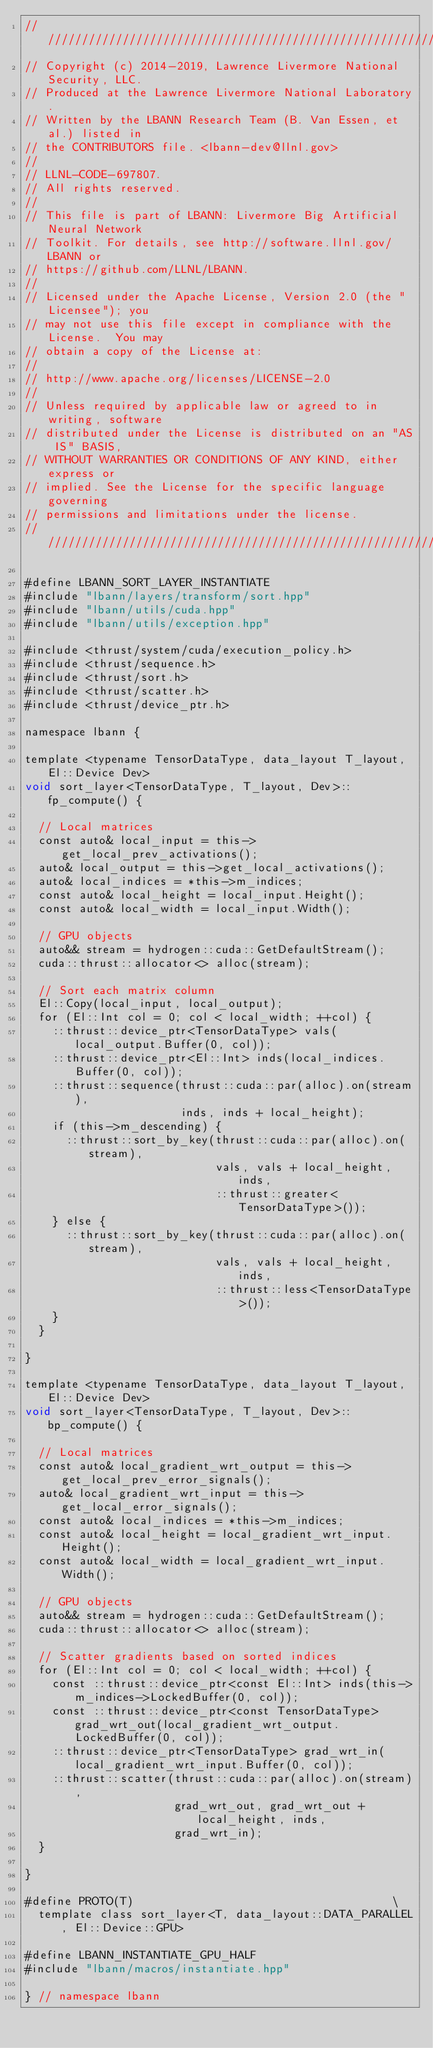Convert code to text. <code><loc_0><loc_0><loc_500><loc_500><_Cuda_>////////////////////////////////////////////////////////////////////////////////
// Copyright (c) 2014-2019, Lawrence Livermore National Security, LLC.
// Produced at the Lawrence Livermore National Laboratory.
// Written by the LBANN Research Team (B. Van Essen, et al.) listed in
// the CONTRIBUTORS file. <lbann-dev@llnl.gov>
//
// LLNL-CODE-697807.
// All rights reserved.
//
// This file is part of LBANN: Livermore Big Artificial Neural Network
// Toolkit. For details, see http://software.llnl.gov/LBANN or
// https://github.com/LLNL/LBANN.
//
// Licensed under the Apache License, Version 2.0 (the "Licensee"); you
// may not use this file except in compliance with the License.  You may
// obtain a copy of the License at:
//
// http://www.apache.org/licenses/LICENSE-2.0
//
// Unless required by applicable law or agreed to in writing, software
// distributed under the License is distributed on an "AS IS" BASIS,
// WITHOUT WARRANTIES OR CONDITIONS OF ANY KIND, either express or
// implied. See the License for the specific language governing
// permissions and limitations under the license.
////////////////////////////////////////////////////////////////////////////////

#define LBANN_SORT_LAYER_INSTANTIATE
#include "lbann/layers/transform/sort.hpp"
#include "lbann/utils/cuda.hpp"
#include "lbann/utils/exception.hpp"

#include <thrust/system/cuda/execution_policy.h>
#include <thrust/sequence.h>
#include <thrust/sort.h>
#include <thrust/scatter.h>
#include <thrust/device_ptr.h>

namespace lbann {

template <typename TensorDataType, data_layout T_layout, El::Device Dev>
void sort_layer<TensorDataType, T_layout, Dev>::fp_compute() {

  // Local matrices
  const auto& local_input = this->get_local_prev_activations();
  auto& local_output = this->get_local_activations();
  auto& local_indices = *this->m_indices;
  const auto& local_height = local_input.Height();
  const auto& local_width = local_input.Width();

  // GPU objects
  auto&& stream = hydrogen::cuda::GetDefaultStream();
  cuda::thrust::allocator<> alloc(stream);

  // Sort each matrix column
  El::Copy(local_input, local_output);
  for (El::Int col = 0; col < local_width; ++col) {
    ::thrust::device_ptr<TensorDataType> vals(local_output.Buffer(0, col));
    ::thrust::device_ptr<El::Int> inds(local_indices.Buffer(0, col));
    ::thrust::sequence(thrust::cuda::par(alloc).on(stream),
                       inds, inds + local_height);
    if (this->m_descending) {
      ::thrust::sort_by_key(thrust::cuda::par(alloc).on(stream),
                            vals, vals + local_height, inds,
                            ::thrust::greater<TensorDataType>());
    } else {
      ::thrust::sort_by_key(thrust::cuda::par(alloc).on(stream),
                            vals, vals + local_height, inds,
                            ::thrust::less<TensorDataType>());
    }
  }

}

template <typename TensorDataType, data_layout T_layout, El::Device Dev>
void sort_layer<TensorDataType, T_layout, Dev>::bp_compute() {

  // Local matrices
  const auto& local_gradient_wrt_output = this->get_local_prev_error_signals();
  auto& local_gradient_wrt_input = this->get_local_error_signals();
  const auto& local_indices = *this->m_indices;
  const auto& local_height = local_gradient_wrt_input.Height();
  const auto& local_width = local_gradient_wrt_input.Width();

  // GPU objects
  auto&& stream = hydrogen::cuda::GetDefaultStream();
  cuda::thrust::allocator<> alloc(stream);

  // Scatter gradients based on sorted indices
  for (El::Int col = 0; col < local_width; ++col) {
    const ::thrust::device_ptr<const El::Int> inds(this->m_indices->LockedBuffer(0, col));
    const ::thrust::device_ptr<const TensorDataType> grad_wrt_out(local_gradient_wrt_output.LockedBuffer(0, col));
    ::thrust::device_ptr<TensorDataType> grad_wrt_in(local_gradient_wrt_input.Buffer(0, col));
    ::thrust::scatter(thrust::cuda::par(alloc).on(stream),
                      grad_wrt_out, grad_wrt_out + local_height, inds,
                      grad_wrt_in);
  }

}

#define PROTO(T)                                      \
  template class sort_layer<T, data_layout::DATA_PARALLEL, El::Device::GPU>

#define LBANN_INSTANTIATE_GPU_HALF
#include "lbann/macros/instantiate.hpp"

} // namespace lbann
</code> 